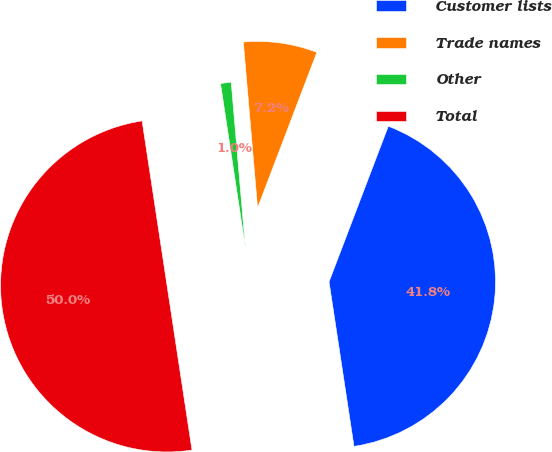Convert chart to OTSL. <chart><loc_0><loc_0><loc_500><loc_500><pie_chart><fcel>Customer lists<fcel>Trade names<fcel>Other<fcel>Total<nl><fcel>41.81%<fcel>7.16%<fcel>1.03%<fcel>50.0%<nl></chart> 